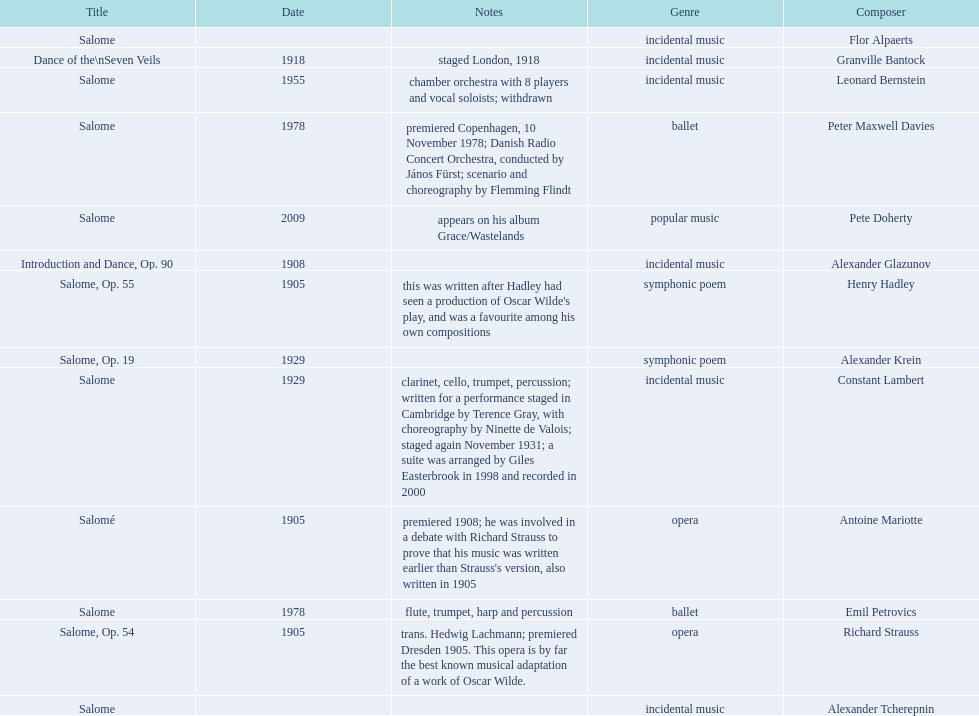How many works were made in the incidental music genre? 6. 